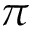Convert formula to latex. <formula><loc_0><loc_0><loc_500><loc_500>\pi</formula> 